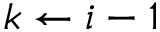Convert formula to latex. <formula><loc_0><loc_0><loc_500><loc_500>k \gets i - 1</formula> 